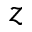<formula> <loc_0><loc_0><loc_500><loc_500>z</formula> 